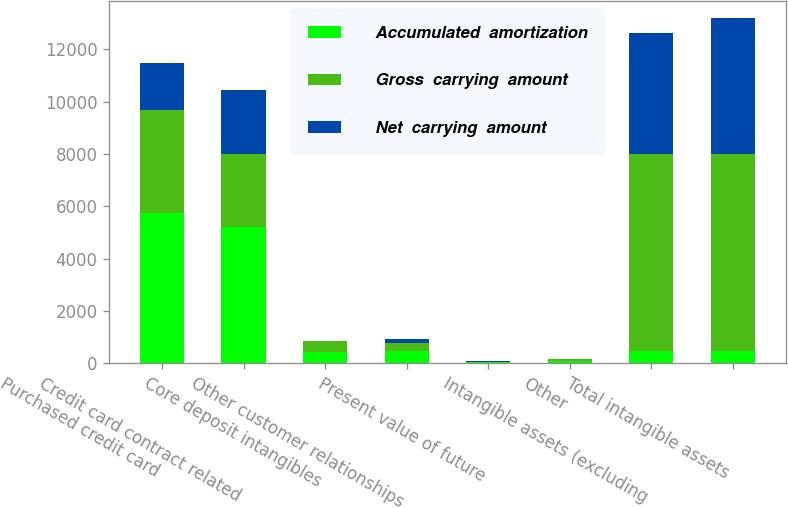Convert chart to OTSL. <chart><loc_0><loc_0><loc_500><loc_500><stacked_bar_chart><ecel><fcel>Purchased credit card<fcel>Credit card contract related<fcel>Core deposit intangibles<fcel>Other customer relationships<fcel>Present value of future<fcel>Other<fcel>Intangible assets (excluding<fcel>Total intangible assets<nl><fcel>Accumulated  amortization<fcel>5733<fcel>5225<fcel>419<fcel>470<fcel>32<fcel>84<fcel>444.5<fcel>444.5<nl><fcel>Gross  carrying  amount<fcel>3936<fcel>2791<fcel>415<fcel>299<fcel>29<fcel>75<fcel>7545<fcel>7545<nl><fcel>Net  carrying  amount<fcel>1797<fcel>2434<fcel>4<fcel>171<fcel>3<fcel>9<fcel>4636<fcel>5220<nl></chart> 